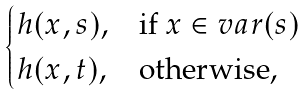Convert formula to latex. <formula><loc_0><loc_0><loc_500><loc_500>\begin{cases} \L h ( x , s ) , & \text {if } x \in v a r ( s ) \\ \L h ( x , t ) , & \text {otherwise,} \end{cases}</formula> 